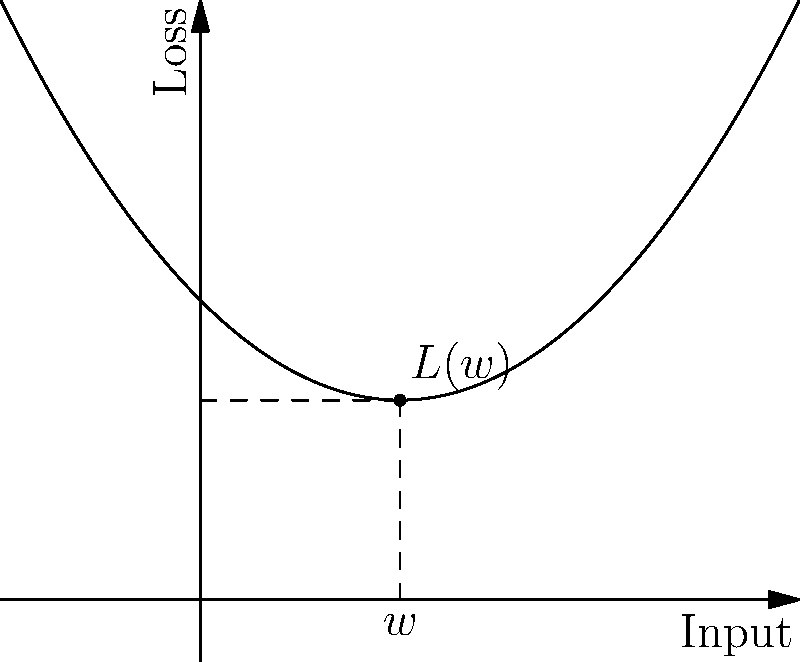Given the graph of a neural network's loss function $L(w)$ with respect to a single weight $w$, calculate the gradient $\frac{\partial L}{\partial w}$ at the point $w=1$. How would this gradient be used in a gradient descent optimization step? To solve this problem, we'll follow these steps:

1) The loss function appears to be a quadratic function of the form $L(w) = a(w-b)^2 + c$, where the vertex is at $(1,1)$.

2) To find $a$, we can use the fact that the function passes through $(0,1.5)$:
   $1.5 = a(0-1)^2 + 1$
   $0.5 = a$

3) Therefore, the function is $L(w) = 0.5(w-1)^2 + 1$

4) To find the gradient, we need to differentiate $L(w)$ with respect to $w$:
   $\frac{\partial L}{\partial w} = 0.5 \cdot 2(w-1) = w-1$

5) At $w=1$, the gradient is:
   $\frac{\partial L}{\partial w}|_{w=1} = 1-1 = 0$

6) In a gradient descent step, we would update $w$ as follows:
   $w_{new} = w_{old} - \alpha \frac{\partial L}{\partial w}$
   where $\alpha$ is the learning rate.

7) Since the gradient is 0 at $w=1$, a gradient descent step would not change $w$, indicating we've reached a local minimum.
Answer: $\frac{\partial L}{\partial w}|_{w=1} = 0$; No weight update in gradient descent as minimum reached. 